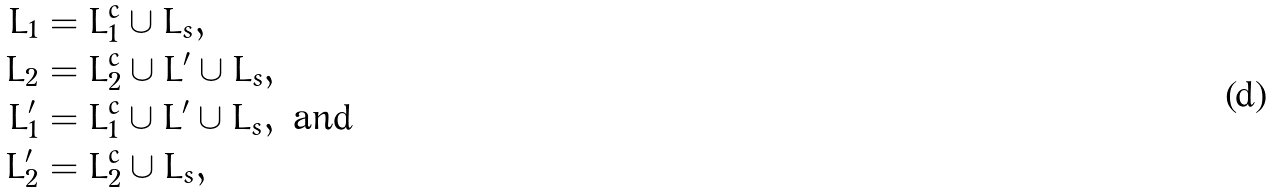Convert formula to latex. <formula><loc_0><loc_0><loc_500><loc_500>L _ { 1 } & = L _ { 1 } ^ { c } \cup L _ { s } , \\ L _ { 2 } & = L _ { 2 } ^ { c } \cup L ^ { \prime } \cup L _ { s } , \\ L ^ { \prime } _ { 1 } & = L _ { 1 } ^ { c } \cup L ^ { \prime } \cup L _ { s } , \text { and} \\ L ^ { \prime } _ { 2 } & = L _ { 2 } ^ { c } \cup L _ { s } ,</formula> 